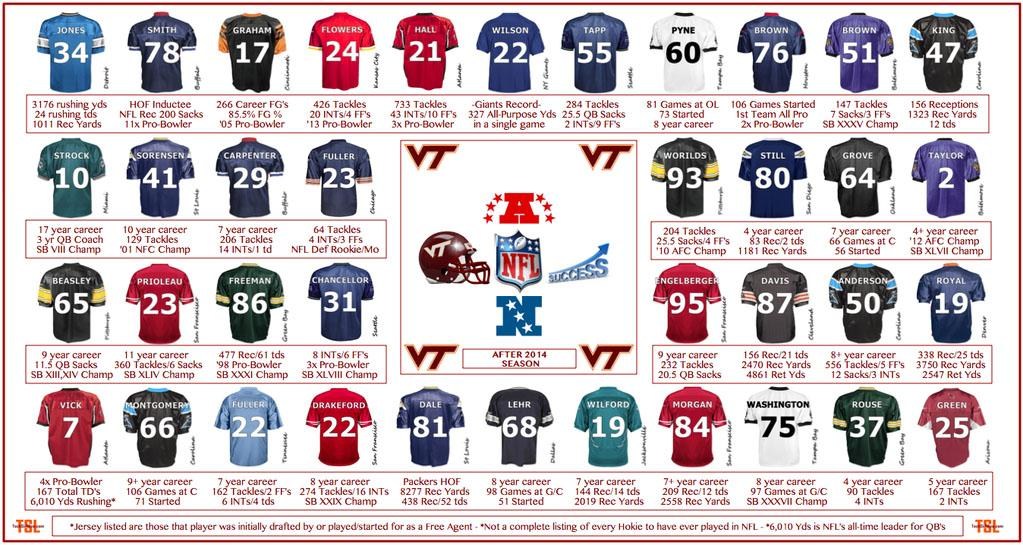Highlight a few significant elements in this photo. The third person in the third row is named Freeman. There are two red jerseys in the first row. Anderson has an 8+ year career, and I am unable to determine the exact year of experience based on the information provided. The jersey number of Royal is 19. According to the information available, Worilds has played a total of 93 tackles. 